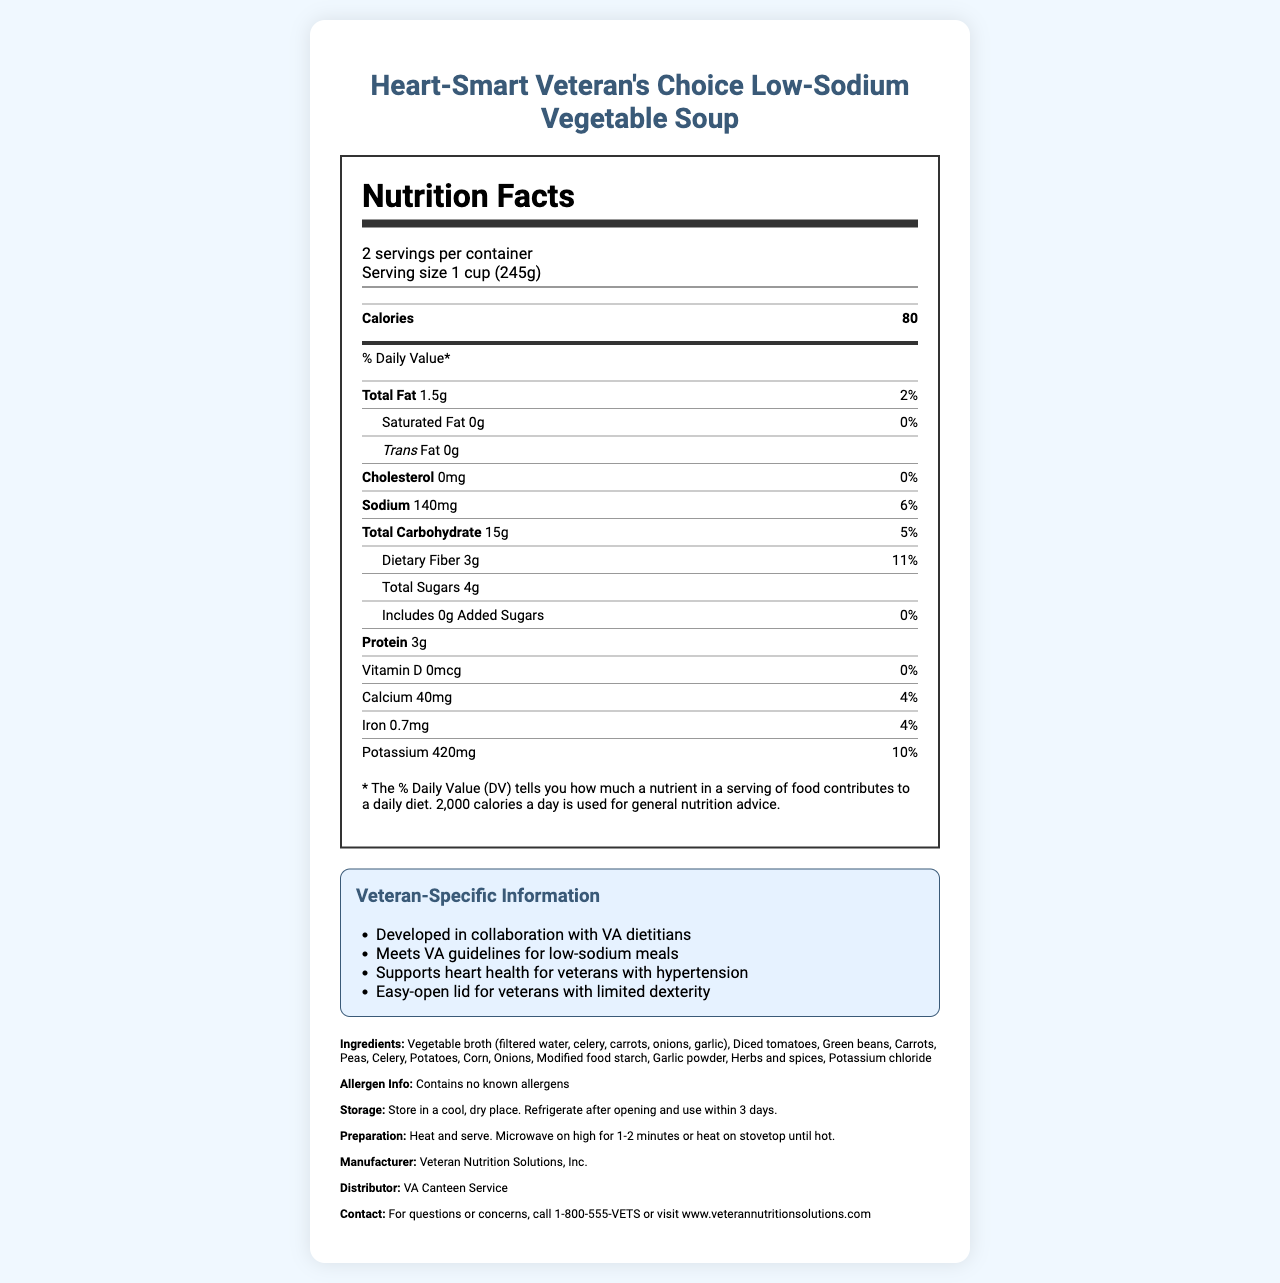what is the serving size? The serving size is clearly listed as "1 cup (245g)" in the Nutrition Facts Label.
Answer: 1 cup (245g) how many servings are in a container? The label states there are "2 servings per container."
Answer: 2 how much sodium is in one serving? The sodium content per serving is listed as "140mg," which is 6% of the daily value.
Answer: 140mg what is the amount of dietary fiber per serving? The dietary fiber content is listed as "3g" per serving.
Answer: 3g how many grams of total sugars are in a serving? According to the label, the total sugar content is "4g" per serving.
Answer: 4g what percentage of the daily value is the total fat per serving? The label shows that the total fat content is 1.5g, which is 2% of the daily value.
Answer: 2% is there any saturated fat in this soup? The label indicates that the saturated fat amount is "0g" and the daily value is "0%."
Answer: No how much protein does one serving contain? A. 2g B. 3g C. 4g D. 5g The label states that one serving contains "3g" of protein.
Answer: B. 3g which nutrient has the highest daily value percentage in this soup? A. Calcium B. Iron C. Potassium D. Dietary Fiber The dietary fiber has an 11% daily value, which is higher than calcium (4%), iron (4%), and potassium (10%).
Answer: D. Dietary Fiber does the soup contain any added sugars? The label specifies "0g" of added sugars indicating there are no added sugars.
Answer: No are there any known allergens in this product? The label mentions "Contains no known allergens."
Answer: No summarize the main features of this canned soup. The summary captures the primary nutritional details and specific features beneficial for veterans with hypertension. It is low in sodium and fat, has no cholesterol or added sugars, and is high in fiber and potassium.
Answer: Heart-Smart Veteran's Choice Low-Sodium Vegetable Soup is a low-sodium, heart-healthy option designed for veterans with hypertension. It contains 80 calories per serving, 1.5g of total fat, and 140mg of sodium. It has no saturated fat, cholesterol, or added sugars, and provides a good source of dietary fiber and potassium. The soup is developed in collaboration with VA dietitians and meets VA guidelines for low-sodium meals. what is the primary ingredient in the vegetable broth? The ingredients list specifies that the vegetable broth contains "filtered water" as its primary component.
Answer: Filtered water how should the soup be stored after opening? The storage instructions state to refrigerate after opening and use within three days.
Answer: Refrigerate after opening and use within 3 days what is the contact information for questions or concerns? The contact information is provided at the end of the document.
Answer: For questions or concerns, call 1-800-555-VETS or visit www.veterannutritionsolutions.com what is the manufacturer's name? The manufacturer's name is listed as "Veteran Nutrition Solutions, Inc."
Answer: Veteran Nutrition Solutions, Inc. how many grams of trans fat are in this soup? The label specifies that the amount of trans fat is "0g."
Answer: 0g is this product a good source of potassium? The label indicates it provides 10% of the daily value for potassium, which qualifies it as a good source.
Answer: Yes does this soup support heart health? The veteran-specific notes mention that this soup supports heart health for veterans with hypertension.
Answer: Yes what is the soup's price? The document does not provide any information regarding the price of the soup.
Answer: Cannot be determined 